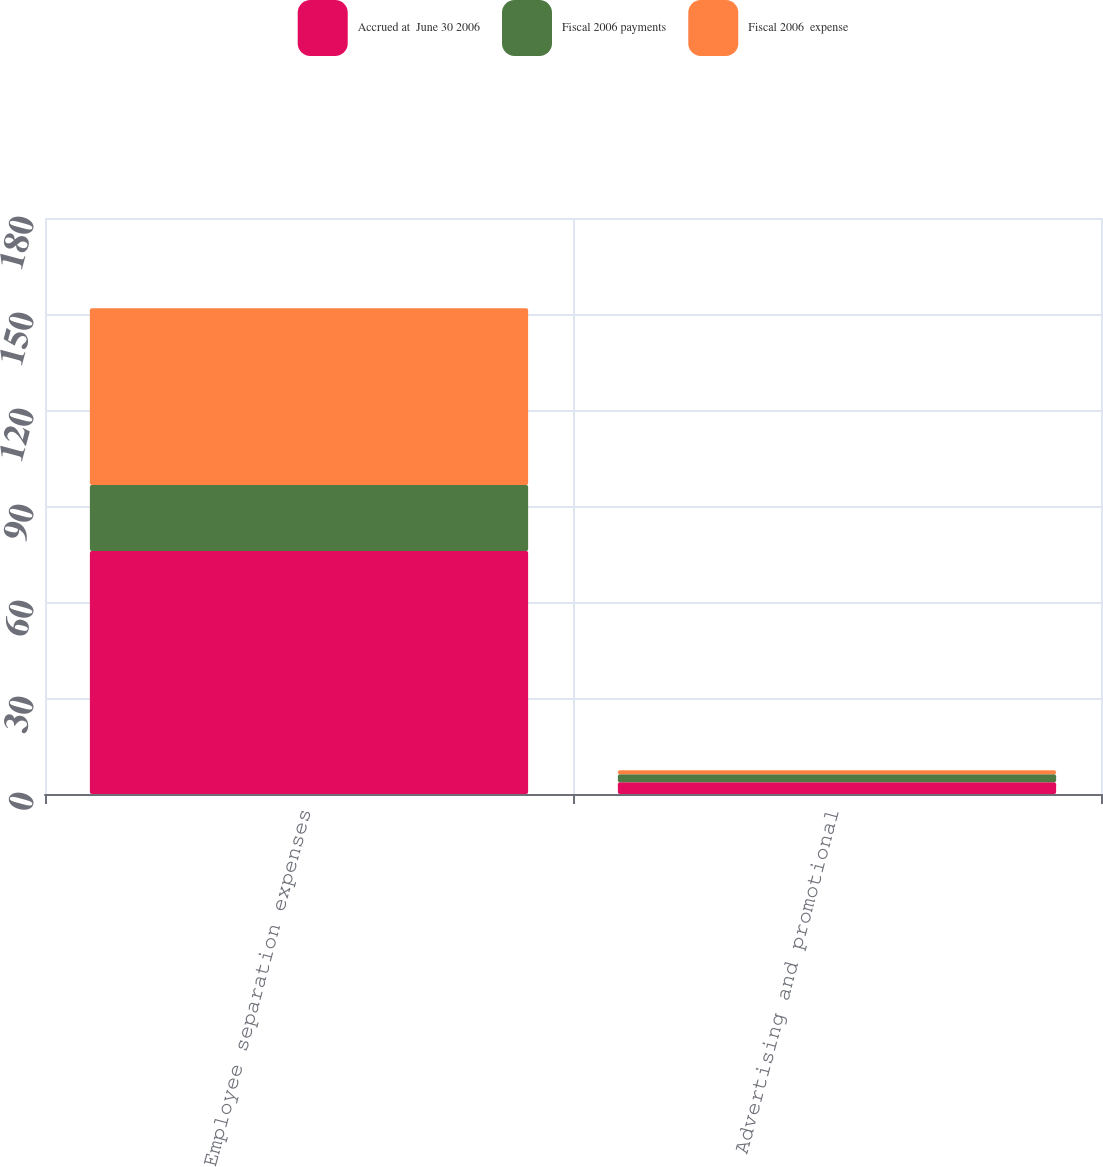Convert chart to OTSL. <chart><loc_0><loc_0><loc_500><loc_500><stacked_bar_chart><ecel><fcel>Employee separation expenses<fcel>Advertising and promotional<nl><fcel>Accrued at  June 30 2006<fcel>75.9<fcel>3.7<nl><fcel>Fiscal 2006 payments<fcel>20.7<fcel>2.5<nl><fcel>Fiscal 2006  expense<fcel>55.2<fcel>1.2<nl></chart> 